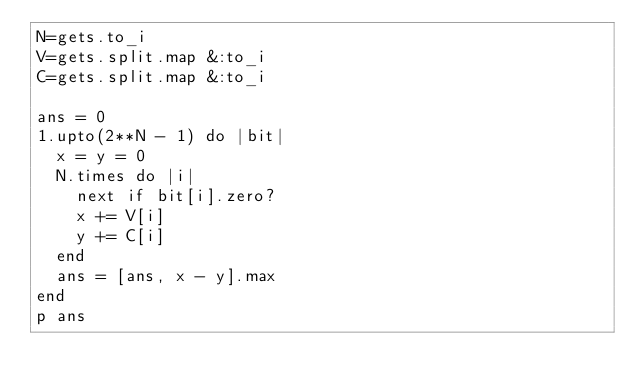<code> <loc_0><loc_0><loc_500><loc_500><_Ruby_>N=gets.to_i
V=gets.split.map &:to_i
C=gets.split.map &:to_i

ans = 0
1.upto(2**N - 1) do |bit|
  x = y = 0
  N.times do |i|
    next if bit[i].zero?
    x += V[i]
    y += C[i]
  end
  ans = [ans, x - y].max
end
p ans
</code> 